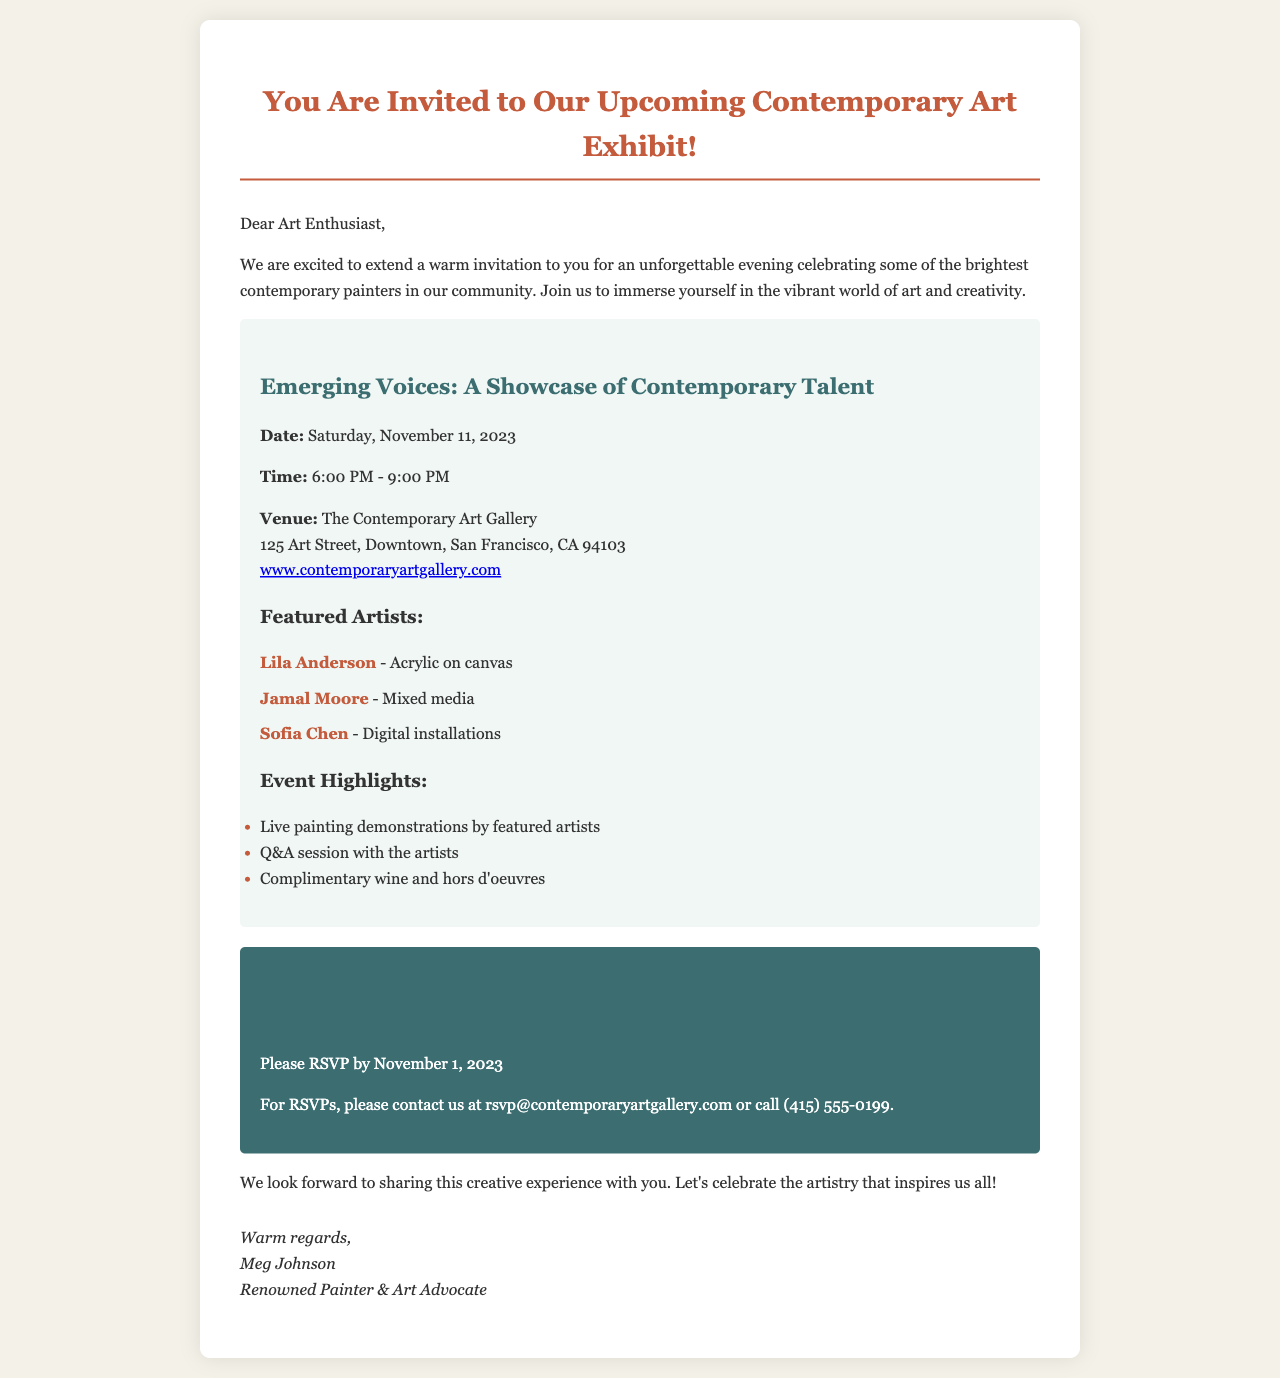what is the date of the art exhibit? The date of the art exhibit is provided in the document as Saturday, November 11, 2023.
Answer: Saturday, November 11, 2023 what is the venue of the event? The venue of the event is stated as The Contemporary Art Gallery, along with its address.
Answer: The Contemporary Art Gallery who is one of the featured artists? The document lists several artists, and asking this question requires retrieval of one of their names.
Answer: Lila Anderson what time does the exhibit start? The starting time of the exhibit is mentioned in the time section of the event details.
Answer: 6:00 PM which medium does Jamal Moore use? Jamal Moore's artistic medium is explicitly mentioned in the document.
Answer: Mixed media how long is the exhibit scheduled to last? The duration of the exhibit can be derived from the start and end times given in the document.
Answer: 3 hours what is the RSVP deadline? The document clearly states the deadline for RSVPs.
Answer: November 1, 2023 what type of refreshments will be provided? The document lists complimentary refreshments available at the event.
Answer: Wine and hors d'oeuvres how can attendees RSVP? The RSVP process is defined within the RSVP information section of the document.
Answer: Email or call 